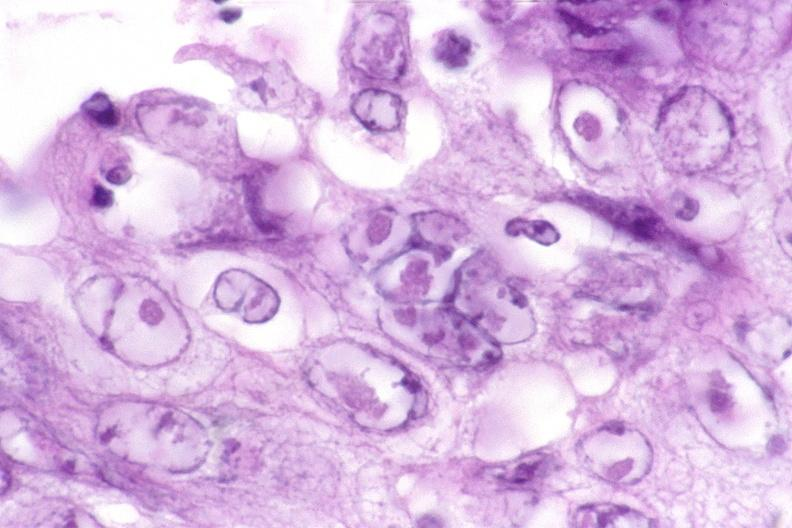s feet present?
Answer the question using a single word or phrase. No 